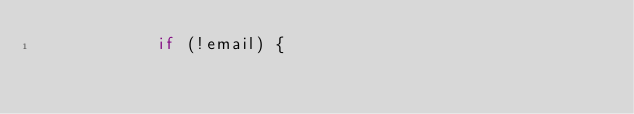<code> <loc_0><loc_0><loc_500><loc_500><_JavaScript_>            if (!email) {</code> 